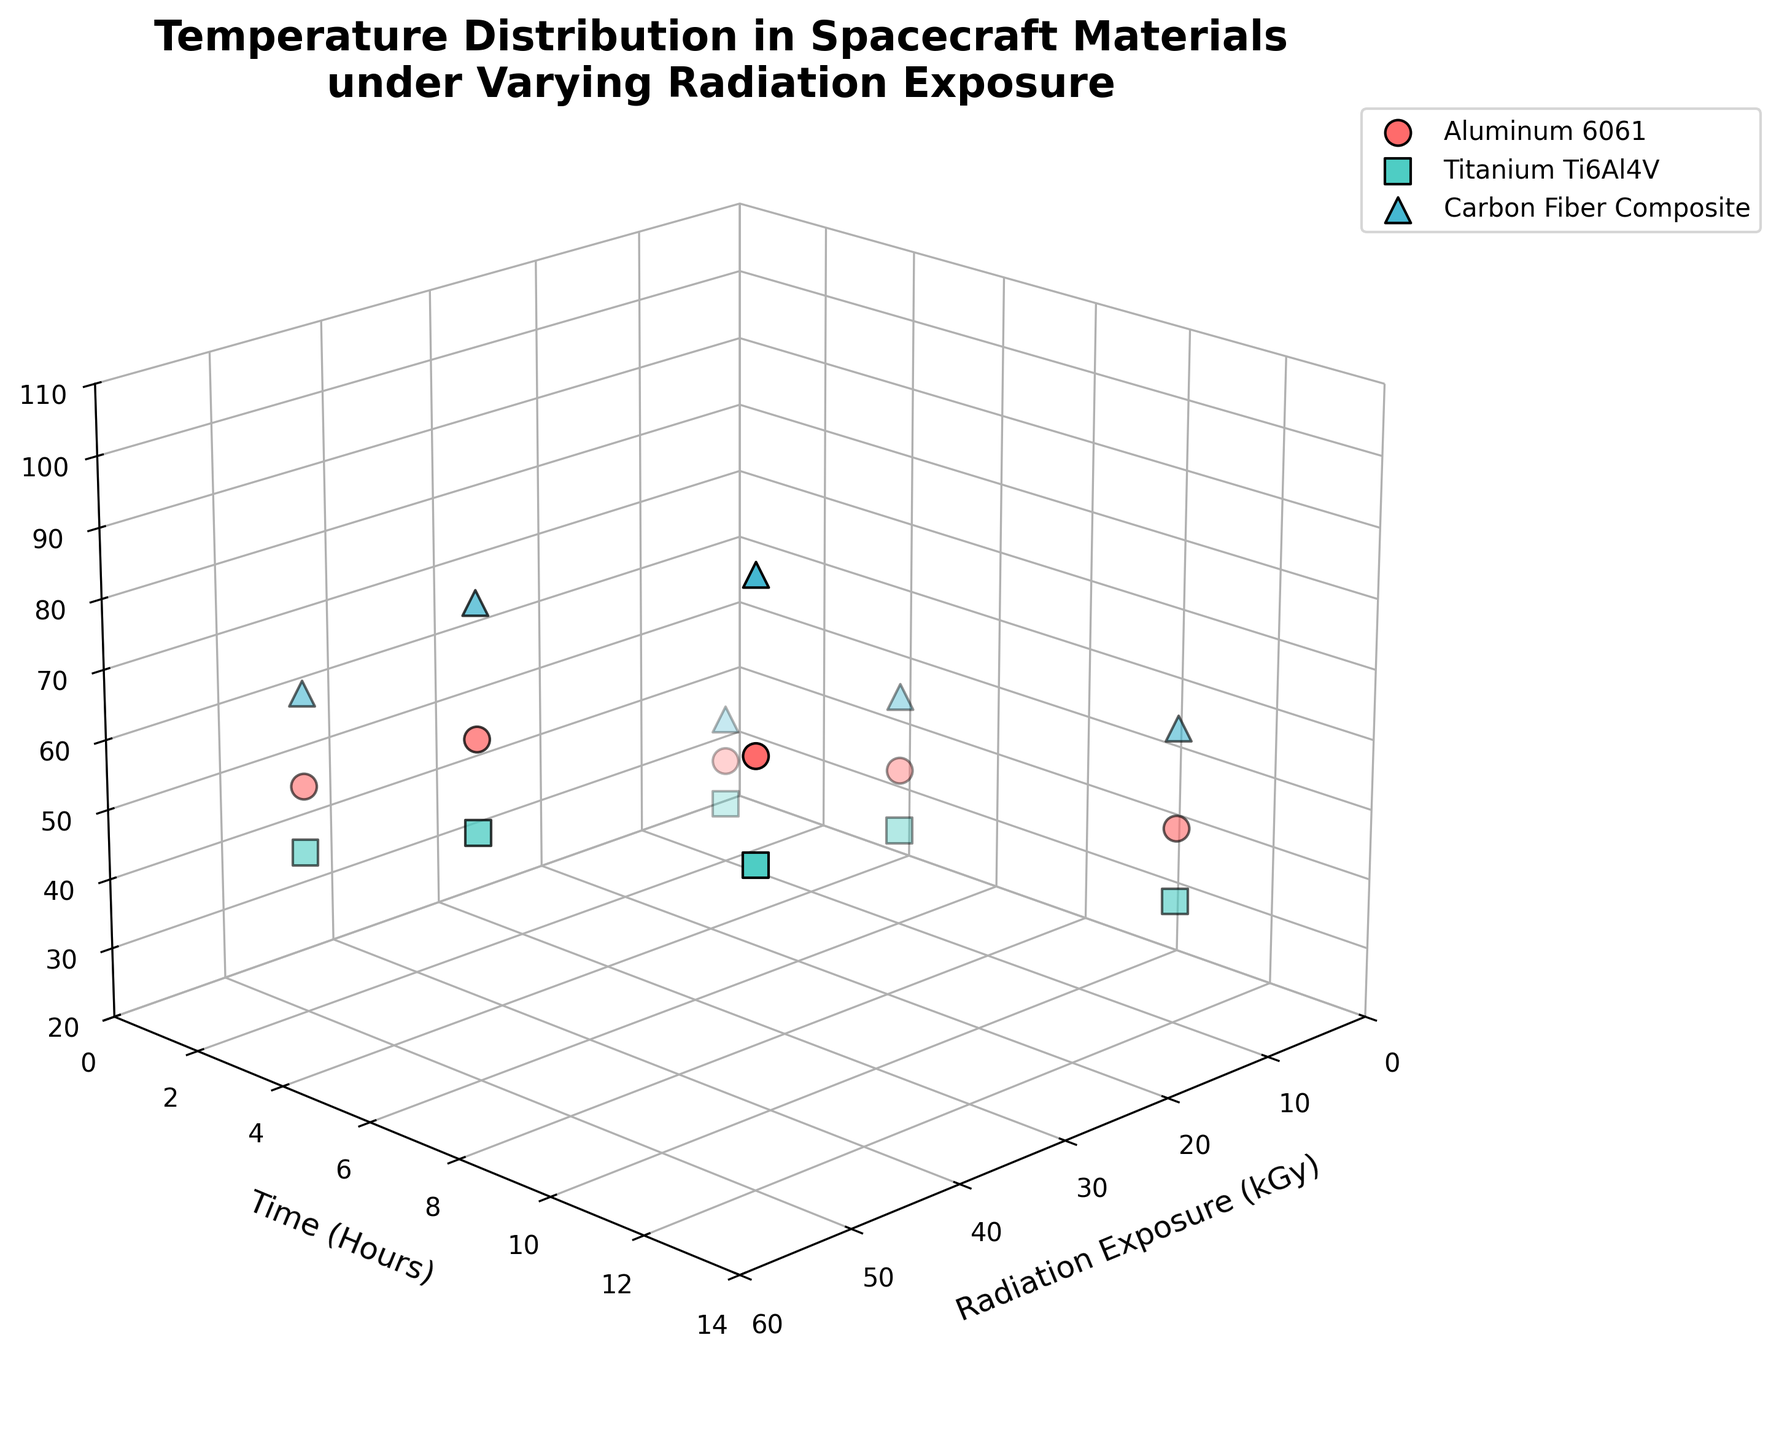How many different materials are shown in the plot? The plot includes data for Aluminum 6061, Titanium Ti6Al4V, and Carbon Fiber Composite.
Answer: 3 Which material shows the highest temperature value, and what is that value? Observing the z-axis, Carbon Fiber Composite at 50 kGy radiation exposure and 12 hours shows the highest temperature value at around 103.6°C.
Answer: Carbon Fiber Composite, 103.6°C For Titanium Ti6Al4V at 2 hours, how does the temperature vary with changes in radiation exposure? For Titanium Ti6Al4V at 2 hours, the temperature increases from 28.7°C at 10 kGy to 43.1°C at 50 kGy.
Answer: It increases from 28.7°C to 43.1°C Compare the temperatures for Aluminum 6061 and Carbon Fiber Composite at 10 kGy and 12 hours. At 10 kGy and 12 hours, Aluminum 6061 reaches 48.1°C, while Carbon Fiber Composite reaches 62.4°C.
Answer: Carbon Fiber Composite is higher at 62.4°C compared to Aluminum 6061 at 48.1°C Which material experiences the largest temperature increase over the 12-hour period at 50 kGy, and by how much? For Carbon Fiber Composite, the temperature increases from 65.9°C at 2 hours to 103.6°C at 12 hours, an increase of 37.7°C.
Answer: Carbon Fiber Composite, 37.7°C At 50 kGy radiation exposure, what is the trend in temperature change for Aluminum 6061 over time? For Aluminum 6061 at 50 kGy, the temperature increases from 52.6°C at 2 hours to 68.3°C at 6 hours, and finally to 79.5°C at 12 hours, showing a consistent increase.
Answer: Consistently increases Does any material show a temperature above 40°C within 2 hours at 10 kGy radiation exposure? Only Carbon Fiber Composite shows a temperature above 40°C at 10 kGy and 2 hours, with a temperature of 41.5°C.
Answer: Carbon Fiber Composite, 41.5°C What is the average temperature for Carbon Fiber Composite at 6 hours across different radiation exposure levels? The temperatures at 6 hours for Carbon Fiber Composite are 53.7°C at 10 kGy and 87.2°C at 50 kGy. Average: (53.7 + 87.2)/2 = 70.45°C.
Answer: 70.45°C How does the temperature for Titanium Ti6Al4V at 50 kGy change as time increases? For Titanium Ti6Al4V at 50 kGy, the temperature increases from 43.1°C at 2 hours to 55.2°C at 6 hours, and finally to 64.8°C at 12 hours.
Answer: It increases At which radiation exposure level does Aluminum 6061 at 6 hours show a higher temperature: 10 kGy or 50 kGy? In the plot, Aluminum 6061 at 6 hours shows higher temperature at 50 kGy (68.3°C) compared to 10 kGy (42.8°C).
Answer: 50 kGy 